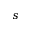<formula> <loc_0><loc_0><loc_500><loc_500>s</formula> 